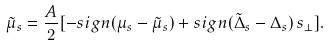Convert formula to latex. <formula><loc_0><loc_0><loc_500><loc_500>\tilde { \mu } _ { s } = \frac { A } { 2 } [ - s i g n ( \mu _ { s } - \tilde { \mu } _ { s } ) + s i g n ( \tilde { \Delta } _ { s } - \Delta _ { s } ) \, s _ { \perp } ] .</formula> 